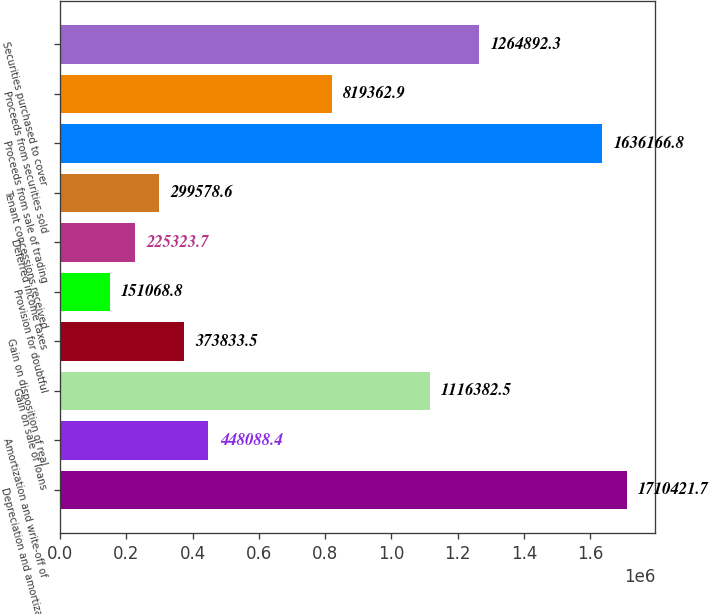Convert chart. <chart><loc_0><loc_0><loc_500><loc_500><bar_chart><fcel>Depreciation and amortization<fcel>Amortization and write-off of<fcel>Gain on sale of loans<fcel>Gain on disposition of real<fcel>Provision for doubtful<fcel>Deferred income taxes<fcel>Tenant concessions received<fcel>Proceeds from sale of trading<fcel>Proceeds from securities sold<fcel>Securities purchased to cover<nl><fcel>1.71042e+06<fcel>448088<fcel>1.11638e+06<fcel>373834<fcel>151069<fcel>225324<fcel>299579<fcel>1.63617e+06<fcel>819363<fcel>1.26489e+06<nl></chart> 